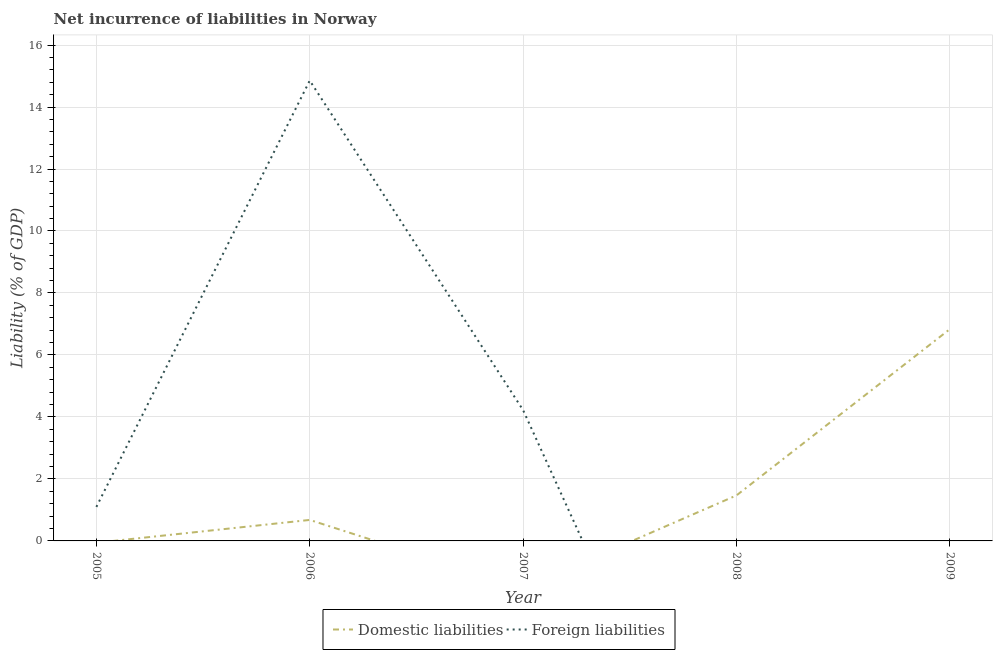Does the line corresponding to incurrence of domestic liabilities intersect with the line corresponding to incurrence of foreign liabilities?
Make the answer very short. Yes. Is the number of lines equal to the number of legend labels?
Your answer should be very brief. No. What is the incurrence of foreign liabilities in 2009?
Your answer should be compact. 0. Across all years, what is the maximum incurrence of domestic liabilities?
Your answer should be very brief. 6.83. Across all years, what is the minimum incurrence of foreign liabilities?
Ensure brevity in your answer.  0. What is the total incurrence of foreign liabilities in the graph?
Provide a short and direct response. 20.17. What is the difference between the incurrence of domestic liabilities in 2006 and that in 2008?
Offer a very short reply. -0.79. What is the difference between the incurrence of foreign liabilities in 2006 and the incurrence of domestic liabilities in 2007?
Give a very brief answer. 14.85. What is the average incurrence of foreign liabilities per year?
Your answer should be very brief. 4.03. In the year 2006, what is the difference between the incurrence of foreign liabilities and incurrence of domestic liabilities?
Ensure brevity in your answer.  14.18. What is the difference between the highest and the second highest incurrence of foreign liabilities?
Offer a very short reply. 10.63. What is the difference between the highest and the lowest incurrence of foreign liabilities?
Ensure brevity in your answer.  14.85. In how many years, is the incurrence of domestic liabilities greater than the average incurrence of domestic liabilities taken over all years?
Make the answer very short. 1. Is the sum of the incurrence of foreign liabilities in 2005 and 2007 greater than the maximum incurrence of domestic liabilities across all years?
Provide a short and direct response. No. Is the incurrence of foreign liabilities strictly greater than the incurrence of domestic liabilities over the years?
Keep it short and to the point. No. How many lines are there?
Ensure brevity in your answer.  2. What is the difference between two consecutive major ticks on the Y-axis?
Your response must be concise. 2. How many legend labels are there?
Provide a short and direct response. 2. How are the legend labels stacked?
Make the answer very short. Horizontal. What is the title of the graph?
Ensure brevity in your answer.  Net incurrence of liabilities in Norway. Does "Not attending school" appear as one of the legend labels in the graph?
Offer a terse response. No. What is the label or title of the X-axis?
Provide a succinct answer. Year. What is the label or title of the Y-axis?
Ensure brevity in your answer.  Liability (% of GDP). What is the Liability (% of GDP) of Foreign liabilities in 2005?
Provide a short and direct response. 1.1. What is the Liability (% of GDP) of Domestic liabilities in 2006?
Keep it short and to the point. 0.68. What is the Liability (% of GDP) of Foreign liabilities in 2006?
Your answer should be compact. 14.85. What is the Liability (% of GDP) in Domestic liabilities in 2007?
Offer a very short reply. 0. What is the Liability (% of GDP) of Foreign liabilities in 2007?
Your response must be concise. 4.22. What is the Liability (% of GDP) of Domestic liabilities in 2008?
Ensure brevity in your answer.  1.47. What is the Liability (% of GDP) in Domestic liabilities in 2009?
Your answer should be compact. 6.83. Across all years, what is the maximum Liability (% of GDP) in Domestic liabilities?
Provide a short and direct response. 6.83. Across all years, what is the maximum Liability (% of GDP) of Foreign liabilities?
Provide a succinct answer. 14.85. What is the total Liability (% of GDP) in Domestic liabilities in the graph?
Make the answer very short. 8.98. What is the total Liability (% of GDP) in Foreign liabilities in the graph?
Keep it short and to the point. 20.17. What is the difference between the Liability (% of GDP) of Foreign liabilities in 2005 and that in 2006?
Keep it short and to the point. -13.76. What is the difference between the Liability (% of GDP) in Foreign liabilities in 2005 and that in 2007?
Provide a short and direct response. -3.12. What is the difference between the Liability (% of GDP) in Foreign liabilities in 2006 and that in 2007?
Offer a terse response. 10.63. What is the difference between the Liability (% of GDP) of Domestic liabilities in 2006 and that in 2008?
Provide a short and direct response. -0.79. What is the difference between the Liability (% of GDP) in Domestic liabilities in 2006 and that in 2009?
Your answer should be compact. -6.16. What is the difference between the Liability (% of GDP) in Domestic liabilities in 2008 and that in 2009?
Provide a short and direct response. -5.36. What is the difference between the Liability (% of GDP) of Domestic liabilities in 2006 and the Liability (% of GDP) of Foreign liabilities in 2007?
Provide a succinct answer. -3.54. What is the average Liability (% of GDP) in Domestic liabilities per year?
Your answer should be compact. 1.8. What is the average Liability (% of GDP) in Foreign liabilities per year?
Make the answer very short. 4.03. In the year 2006, what is the difference between the Liability (% of GDP) in Domestic liabilities and Liability (% of GDP) in Foreign liabilities?
Give a very brief answer. -14.18. What is the ratio of the Liability (% of GDP) in Foreign liabilities in 2005 to that in 2006?
Your answer should be compact. 0.07. What is the ratio of the Liability (% of GDP) in Foreign liabilities in 2005 to that in 2007?
Keep it short and to the point. 0.26. What is the ratio of the Liability (% of GDP) in Foreign liabilities in 2006 to that in 2007?
Make the answer very short. 3.52. What is the ratio of the Liability (% of GDP) of Domestic liabilities in 2006 to that in 2008?
Your response must be concise. 0.46. What is the ratio of the Liability (% of GDP) in Domestic liabilities in 2006 to that in 2009?
Make the answer very short. 0.1. What is the ratio of the Liability (% of GDP) in Domestic liabilities in 2008 to that in 2009?
Your response must be concise. 0.21. What is the difference between the highest and the second highest Liability (% of GDP) of Domestic liabilities?
Your answer should be very brief. 5.36. What is the difference between the highest and the second highest Liability (% of GDP) of Foreign liabilities?
Provide a short and direct response. 10.63. What is the difference between the highest and the lowest Liability (% of GDP) in Domestic liabilities?
Provide a short and direct response. 6.83. What is the difference between the highest and the lowest Liability (% of GDP) of Foreign liabilities?
Keep it short and to the point. 14.85. 